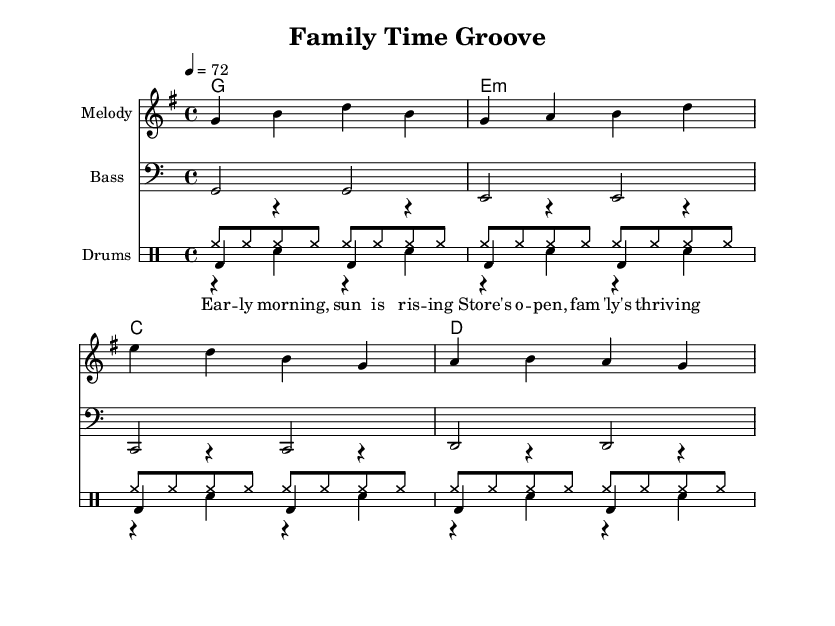What is the key signature of this music? The key signature shown at the beginning of the score indicates that it is G major, which has one sharp (F#).
Answer: G major What is the time signature of this music? The time signature, denoted at the beginning of the score, is 4/4, meaning there are four beats per measure and the quarter note gets one beat.
Answer: 4/4 What is the tempo marking of this piece? The tempo marking indicates that the piece should be played at 72 beats per minute, which is indicated at the start of the score.
Answer: 72 How many measures are there in the melody? By counting the groups of bar lines in the melody section, there are four measures.
Answer: 4 What chords are used in this piece? The chord names shown above the staff indicate that the chords used are G, E minor, C, and D, presented in the chord progression.
Answer: G, E minor, C, D What is the main focus of the lyrics in this reggae tune? The lyrics emphasize themes of family and daily life, highlighting the joy of morning and family thriving, which is a common reggae theme.
Answer: Family values Why is the bass line important in reggae music? In reggae, the bass line provides a deep, laid-back groove that complements the rhythm and creates a foundation for the rest of the music; it plays a significant role in maintaining the reggae feel.
Answer: Foundation of the groove 